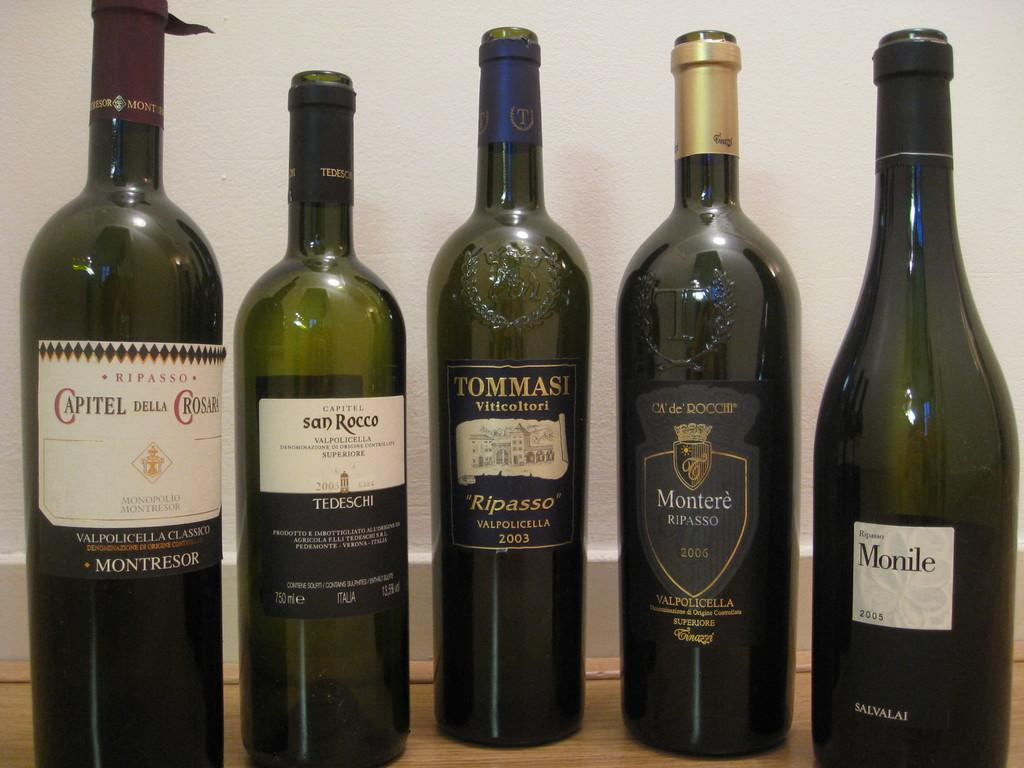How many bottles are visible on the table in the image? There are five bottles on the table. What can be seen in the background of the image? There is a wall in the background of the image. Who is the owner of the bubble in the image? There is no bubble present in the image, so it is not possible to determine the owner. 